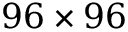Convert formula to latex. <formula><loc_0><loc_0><loc_500><loc_500>9 6 \times 9 6</formula> 